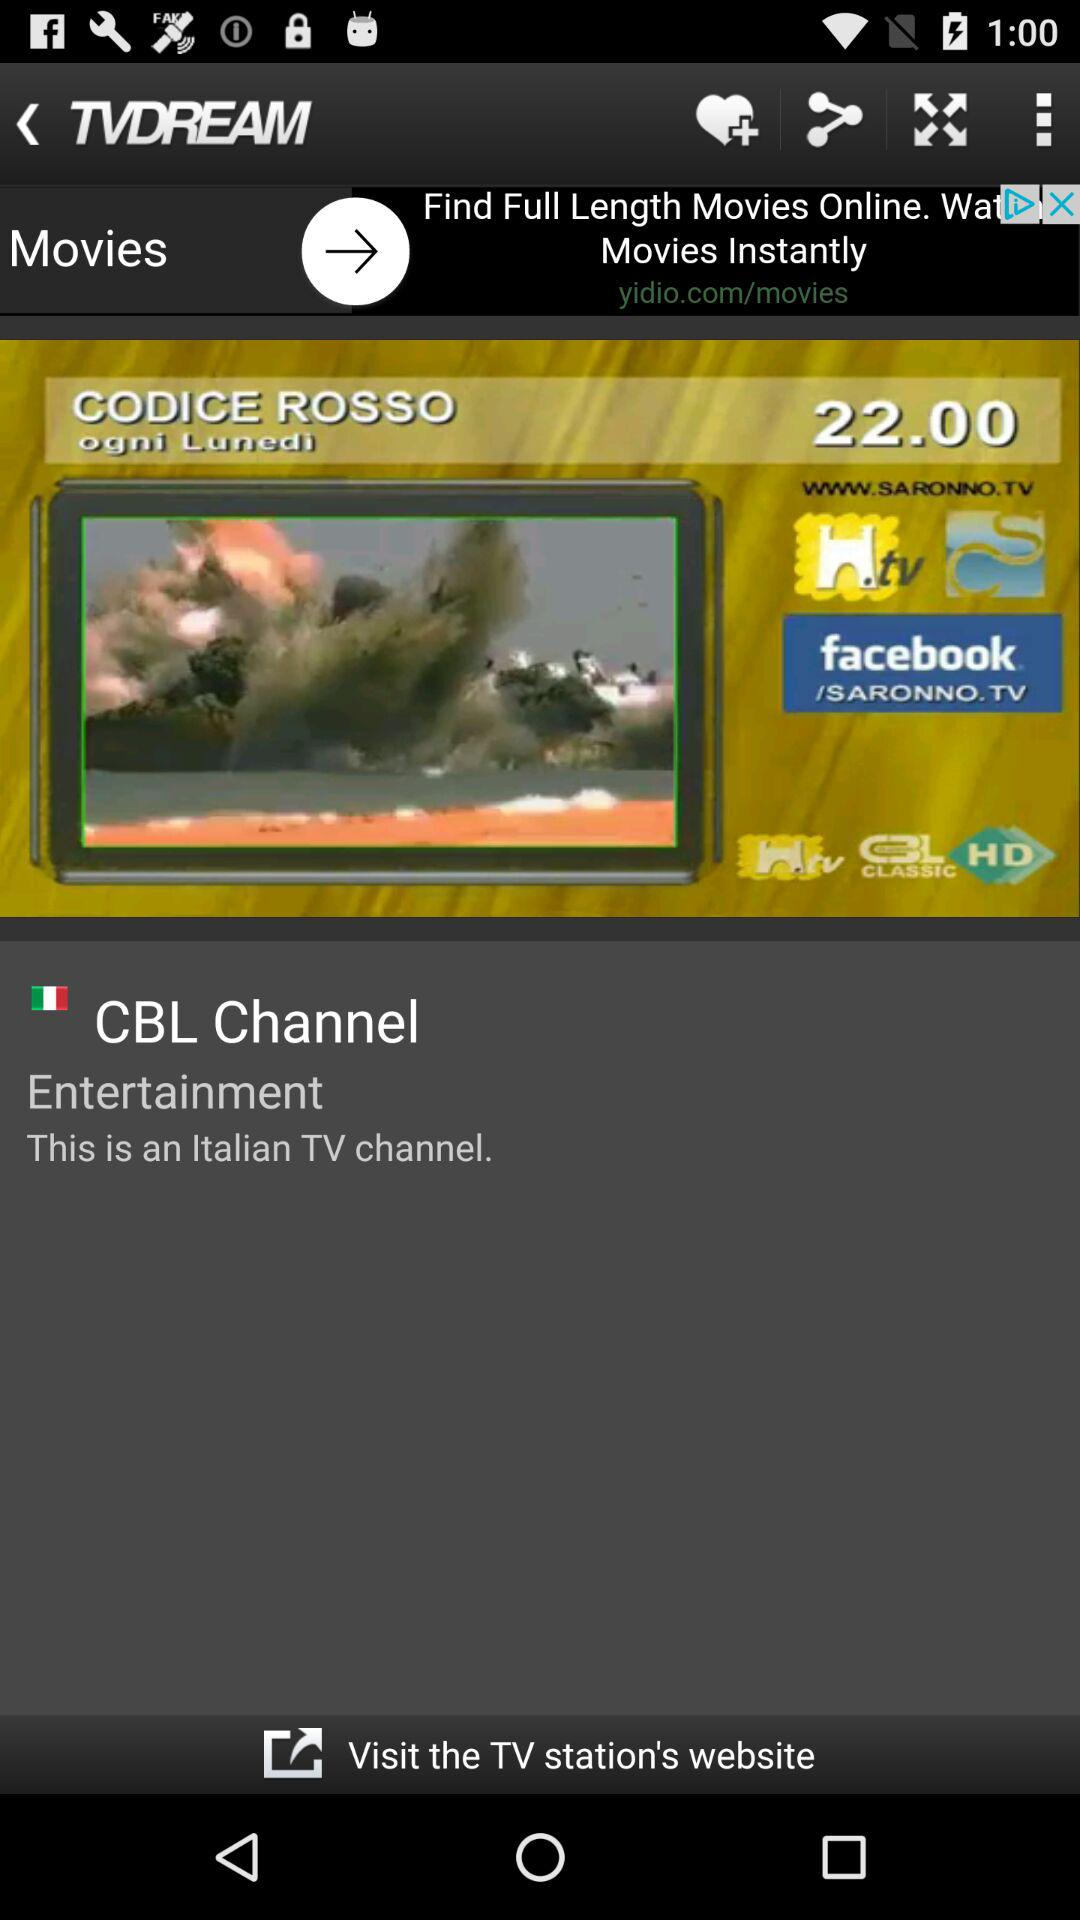What is the channel name? The channel name is "CBL Channel". 